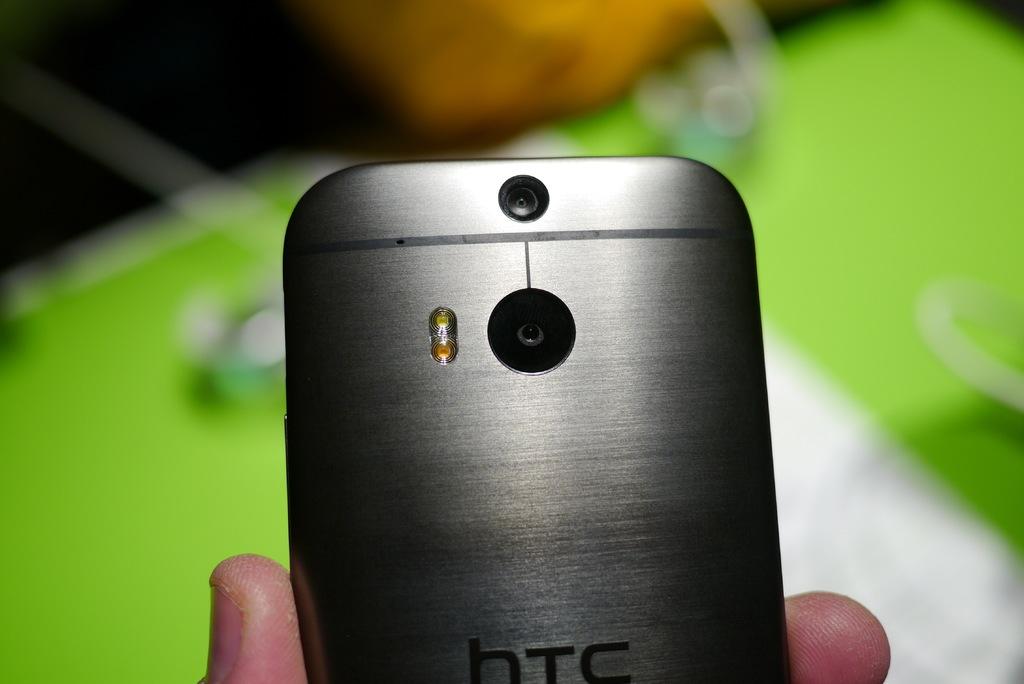What are the 3 letters on the phone?
Provide a short and direct response. Htc. Is this an htc phone?
Ensure brevity in your answer.  Yes. 